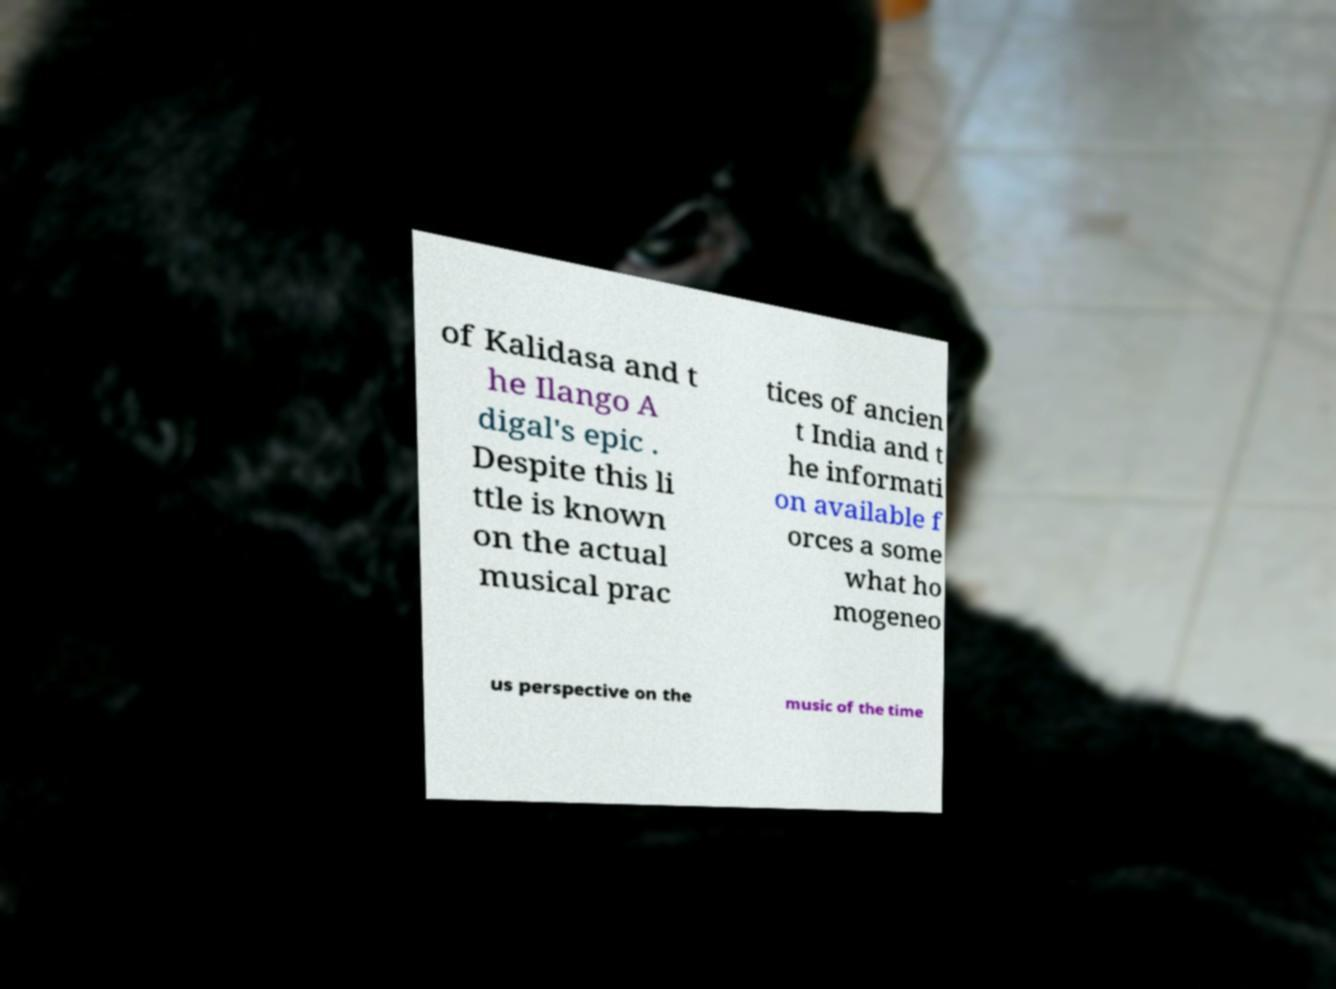There's text embedded in this image that I need extracted. Can you transcribe it verbatim? of Kalidasa and t he Ilango A digal's epic . Despite this li ttle is known on the actual musical prac tices of ancien t India and t he informati on available f orces a some what ho mogeneo us perspective on the music of the time 